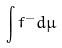Convert formula to latex. <formula><loc_0><loc_0><loc_500><loc_500>\int f ^ { - } d \mu</formula> 